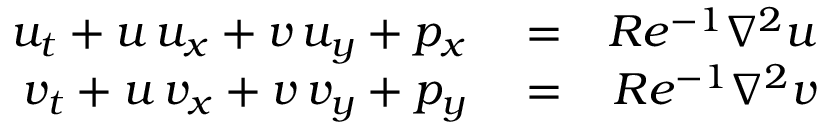<formula> <loc_0><loc_0><loc_500><loc_500>\begin{array} { r l r } { u _ { t } + u \, u _ { x } + v \, u _ { y } + p _ { x } } & = } & { R e ^ { - 1 } \nabla ^ { 2 } u } \\ { v _ { t } + u \, v _ { x } + v \, v _ { y } + p _ { y } } & = } & { R e ^ { - 1 } \nabla ^ { 2 } v } \end{array}</formula> 